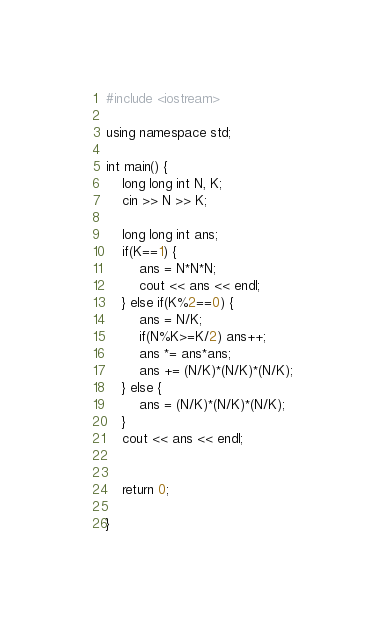Convert code to text. <code><loc_0><loc_0><loc_500><loc_500><_C++_>#include <iostream>

using namespace std;

int main() {
    long long int N, K;
    cin >> N >> K;
    
    long long int ans;
    if(K==1) {
        ans = N*N*N;
        cout << ans << endl;
    } else if(K%2==0) {
        ans = N/K;
        if(N%K>=K/2) ans++;
        ans *= ans*ans;
        ans += (N/K)*(N/K)*(N/K);
    } else {
        ans = (N/K)*(N/K)*(N/K);
    }
    cout << ans << endl;
    

    return 0;
    
}</code> 